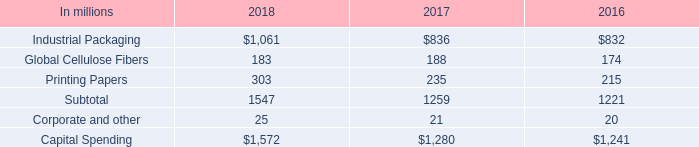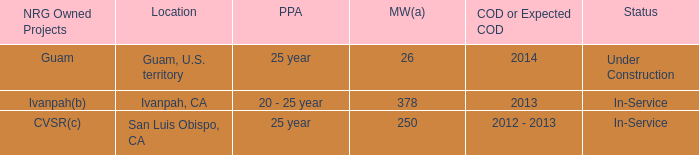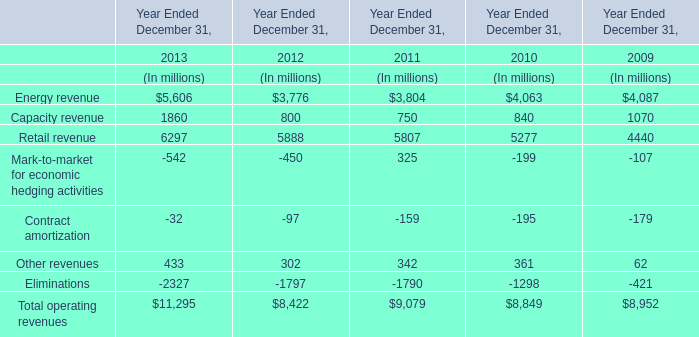what is the growth observed in the industrial packaging segment , during 2017 and 2018? 
Computations: ((1061 / 836) - 1)
Answer: 0.26914. 